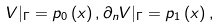<formula> <loc_0><loc_0><loc_500><loc_500>V | _ { \Gamma } = p _ { 0 } \left ( x \right ) , \partial _ { n } V | _ { \Gamma } = p _ { 1 } \left ( x \right ) ,</formula> 